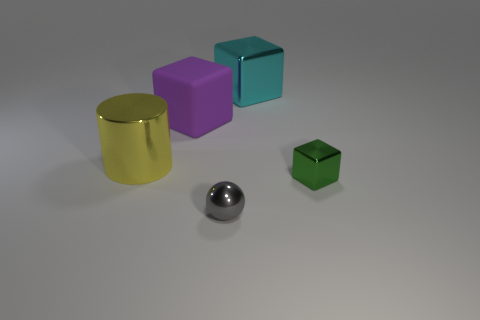Subtract all green cubes. How many cubes are left? 2 Subtract 1 blocks. How many blocks are left? 2 Subtract all purple cubes. How many cubes are left? 2 Add 1 big shiny things. How many objects exist? 6 Subtract all blue cubes. How many green balls are left? 0 Subtract all brown balls. Subtract all cyan cylinders. How many balls are left? 1 Subtract all metal things. Subtract all green things. How many objects are left? 0 Add 4 cyan blocks. How many cyan blocks are left? 5 Add 3 yellow rubber cylinders. How many yellow rubber cylinders exist? 3 Subtract 0 purple balls. How many objects are left? 5 